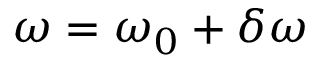Convert formula to latex. <formula><loc_0><loc_0><loc_500><loc_500>\omega = \omega _ { 0 } + \delta \omega</formula> 